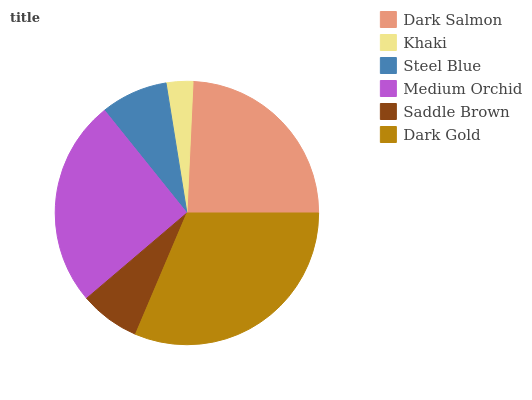Is Khaki the minimum?
Answer yes or no. Yes. Is Dark Gold the maximum?
Answer yes or no. Yes. Is Steel Blue the minimum?
Answer yes or no. No. Is Steel Blue the maximum?
Answer yes or no. No. Is Steel Blue greater than Khaki?
Answer yes or no. Yes. Is Khaki less than Steel Blue?
Answer yes or no. Yes. Is Khaki greater than Steel Blue?
Answer yes or no. No. Is Steel Blue less than Khaki?
Answer yes or no. No. Is Dark Salmon the high median?
Answer yes or no. Yes. Is Steel Blue the low median?
Answer yes or no. Yes. Is Medium Orchid the high median?
Answer yes or no. No. Is Dark Gold the low median?
Answer yes or no. No. 